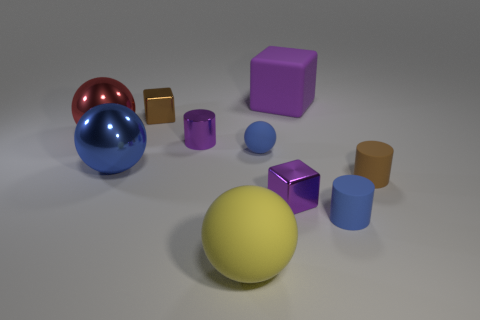Subtract all small balls. How many balls are left? 3 Subtract all yellow spheres. How many spheres are left? 3 Subtract 1 spheres. How many spheres are left? 3 Subtract all green spheres. Subtract all gray cubes. How many spheres are left? 4 Subtract all cubes. How many objects are left? 7 Add 2 large purple objects. How many large purple objects are left? 3 Add 5 big balls. How many big balls exist? 8 Subtract 1 brown cylinders. How many objects are left? 9 Subtract all large purple rubber cylinders. Subtract all cylinders. How many objects are left? 7 